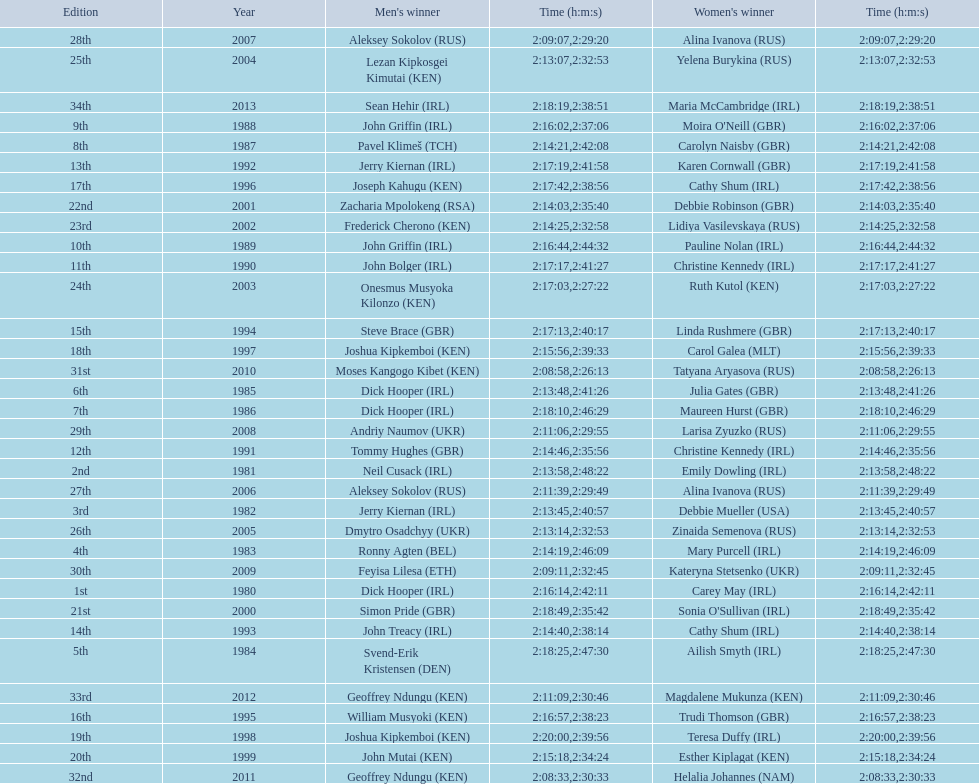Which country is represented for both men and women at the top of the list? Ireland. 